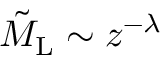<formula> <loc_0><loc_0><loc_500><loc_500>\tilde { M } _ { L } \sim z ^ { - \lambda }</formula> 